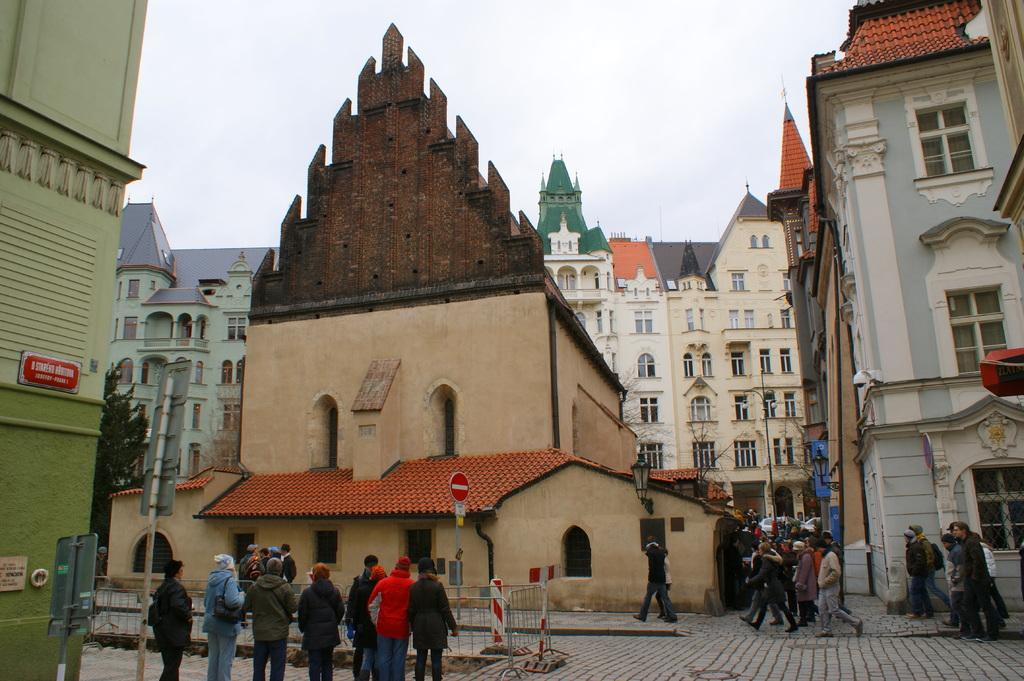How many persons can be seen in the image? There are persons in the image. What is the purpose of the sign board in the image? The purpose of the sign board cannot be determined from the image alone. What type of lighting is present on the road in the image? There are street lights on the road in the image. What can be seen in the background of the image? There are buildings, trees, and the sky visible in the background of the image. What invention is being demonstrated by the persons in the image? There is no invention being demonstrated by the persons in the image; they are simply present in the scene. 